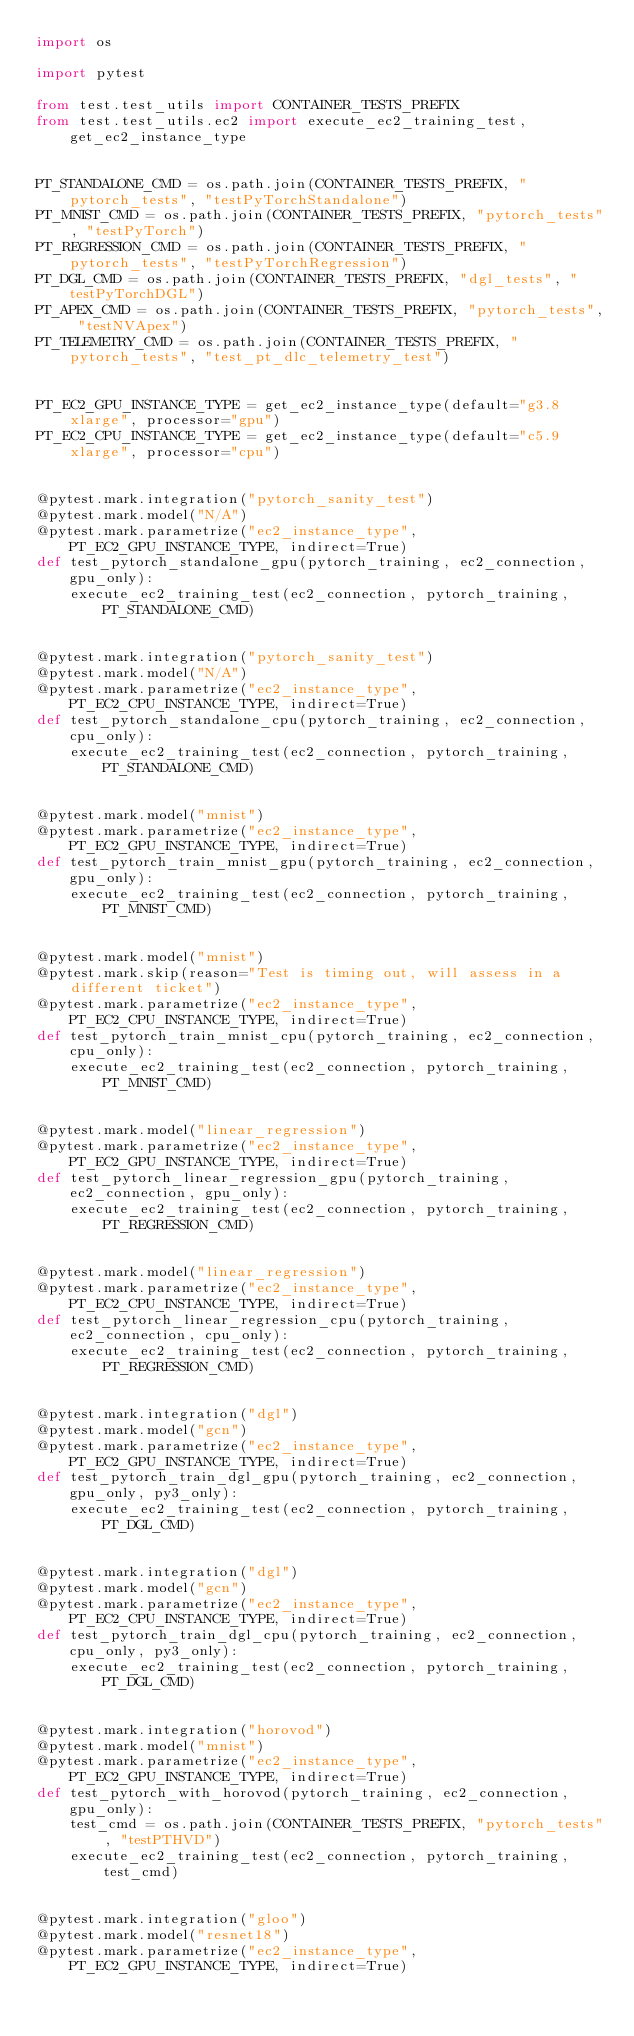<code> <loc_0><loc_0><loc_500><loc_500><_Python_>import os

import pytest

from test.test_utils import CONTAINER_TESTS_PREFIX
from test.test_utils.ec2 import execute_ec2_training_test, get_ec2_instance_type


PT_STANDALONE_CMD = os.path.join(CONTAINER_TESTS_PREFIX, "pytorch_tests", "testPyTorchStandalone")
PT_MNIST_CMD = os.path.join(CONTAINER_TESTS_PREFIX, "pytorch_tests", "testPyTorch")
PT_REGRESSION_CMD = os.path.join(CONTAINER_TESTS_PREFIX, "pytorch_tests", "testPyTorchRegression")
PT_DGL_CMD = os.path.join(CONTAINER_TESTS_PREFIX, "dgl_tests", "testPyTorchDGL")
PT_APEX_CMD = os.path.join(CONTAINER_TESTS_PREFIX, "pytorch_tests", "testNVApex")
PT_TELEMETRY_CMD = os.path.join(CONTAINER_TESTS_PREFIX, "pytorch_tests", "test_pt_dlc_telemetry_test")


PT_EC2_GPU_INSTANCE_TYPE = get_ec2_instance_type(default="g3.8xlarge", processor="gpu")
PT_EC2_CPU_INSTANCE_TYPE = get_ec2_instance_type(default="c5.9xlarge", processor="cpu")


@pytest.mark.integration("pytorch_sanity_test")
@pytest.mark.model("N/A")
@pytest.mark.parametrize("ec2_instance_type", PT_EC2_GPU_INSTANCE_TYPE, indirect=True)
def test_pytorch_standalone_gpu(pytorch_training, ec2_connection, gpu_only):
    execute_ec2_training_test(ec2_connection, pytorch_training, PT_STANDALONE_CMD)


@pytest.mark.integration("pytorch_sanity_test")
@pytest.mark.model("N/A")
@pytest.mark.parametrize("ec2_instance_type", PT_EC2_CPU_INSTANCE_TYPE, indirect=True)
def test_pytorch_standalone_cpu(pytorch_training, ec2_connection, cpu_only):
    execute_ec2_training_test(ec2_connection, pytorch_training, PT_STANDALONE_CMD)


@pytest.mark.model("mnist")
@pytest.mark.parametrize("ec2_instance_type", PT_EC2_GPU_INSTANCE_TYPE, indirect=True)
def test_pytorch_train_mnist_gpu(pytorch_training, ec2_connection, gpu_only):
    execute_ec2_training_test(ec2_connection, pytorch_training, PT_MNIST_CMD)


@pytest.mark.model("mnist")
@pytest.mark.skip(reason="Test is timing out, will assess in a different ticket")
@pytest.mark.parametrize("ec2_instance_type", PT_EC2_CPU_INSTANCE_TYPE, indirect=True)
def test_pytorch_train_mnist_cpu(pytorch_training, ec2_connection, cpu_only):
    execute_ec2_training_test(ec2_connection, pytorch_training, PT_MNIST_CMD)


@pytest.mark.model("linear_regression")
@pytest.mark.parametrize("ec2_instance_type", PT_EC2_GPU_INSTANCE_TYPE, indirect=True)
def test_pytorch_linear_regression_gpu(pytorch_training, ec2_connection, gpu_only):
    execute_ec2_training_test(ec2_connection, pytorch_training, PT_REGRESSION_CMD)


@pytest.mark.model("linear_regression")
@pytest.mark.parametrize("ec2_instance_type", PT_EC2_CPU_INSTANCE_TYPE, indirect=True)
def test_pytorch_linear_regression_cpu(pytorch_training, ec2_connection, cpu_only):
    execute_ec2_training_test(ec2_connection, pytorch_training, PT_REGRESSION_CMD)


@pytest.mark.integration("dgl")
@pytest.mark.model("gcn")
@pytest.mark.parametrize("ec2_instance_type", PT_EC2_GPU_INSTANCE_TYPE, indirect=True)
def test_pytorch_train_dgl_gpu(pytorch_training, ec2_connection, gpu_only, py3_only):
    execute_ec2_training_test(ec2_connection, pytorch_training, PT_DGL_CMD)


@pytest.mark.integration("dgl")
@pytest.mark.model("gcn")
@pytest.mark.parametrize("ec2_instance_type", PT_EC2_CPU_INSTANCE_TYPE, indirect=True)
def test_pytorch_train_dgl_cpu(pytorch_training, ec2_connection, cpu_only, py3_only):
    execute_ec2_training_test(ec2_connection, pytorch_training, PT_DGL_CMD)


@pytest.mark.integration("horovod")
@pytest.mark.model("mnist")
@pytest.mark.parametrize("ec2_instance_type", PT_EC2_GPU_INSTANCE_TYPE, indirect=True)
def test_pytorch_with_horovod(pytorch_training, ec2_connection, gpu_only):
    test_cmd = os.path.join(CONTAINER_TESTS_PREFIX, "pytorch_tests", "testPTHVD")
    execute_ec2_training_test(ec2_connection, pytorch_training, test_cmd)


@pytest.mark.integration("gloo")
@pytest.mark.model("resnet18")
@pytest.mark.parametrize("ec2_instance_type", PT_EC2_GPU_INSTANCE_TYPE, indirect=True)</code> 